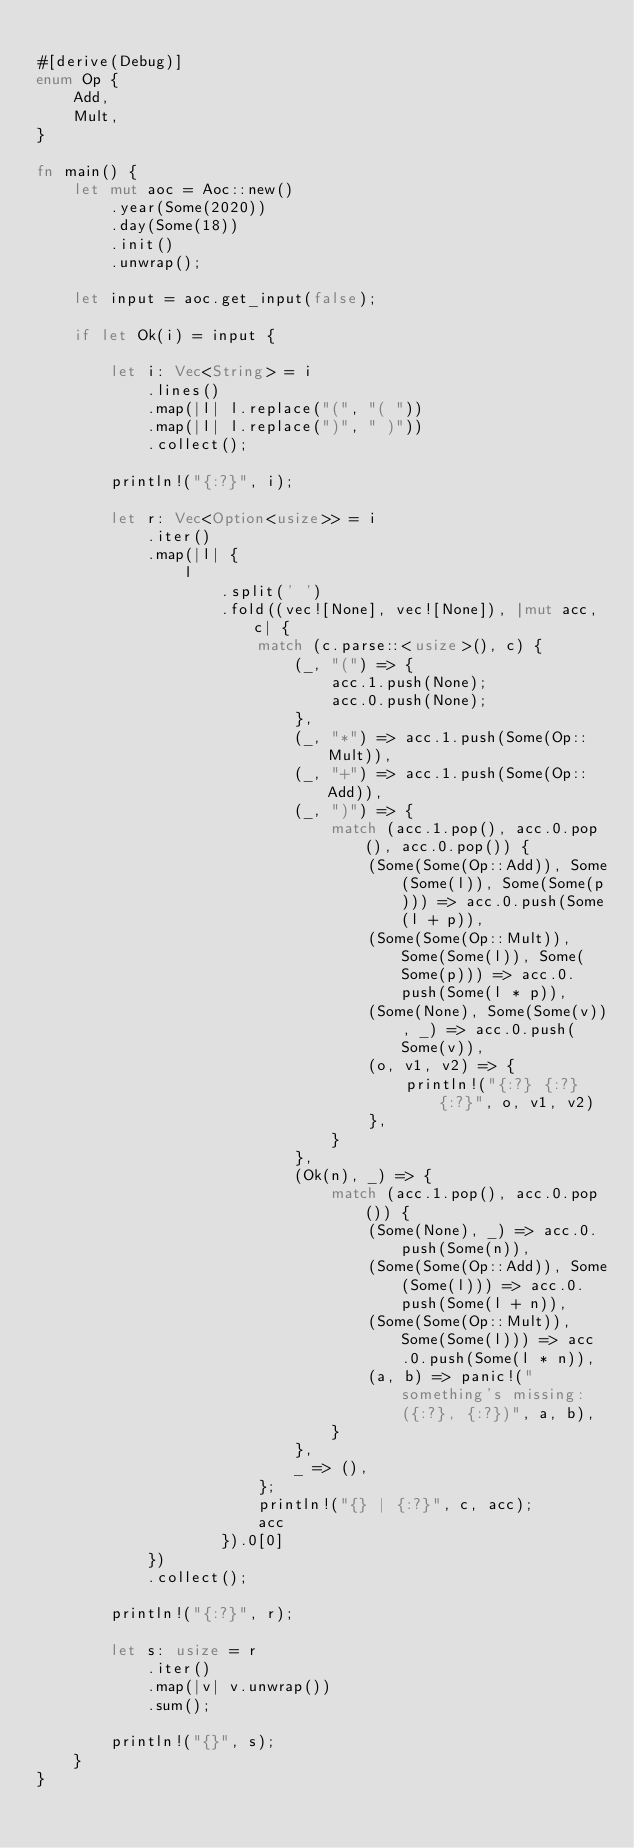<code> <loc_0><loc_0><loc_500><loc_500><_Rust_>
#[derive(Debug)]
enum Op {
    Add,
    Mult,
}

fn main() {
    let mut aoc = Aoc::new()
        .year(Some(2020))
        .day(Some(18))
        .init()
        .unwrap();

    let input = aoc.get_input(false);

    if let Ok(i) = input {

        let i: Vec<String> = i
            .lines()
            .map(|l| l.replace("(", "( "))
            .map(|l| l.replace(")", " )"))
            .collect();

        println!("{:?}", i);

        let r: Vec<Option<usize>> = i
            .iter()
            .map(|l| {
                l
                    .split(' ')
                    .fold((vec![None], vec![None]), |mut acc, c| {
                        match (c.parse::<usize>(), c) {
                            (_, "(") => {
                                acc.1.push(None);
                                acc.0.push(None);
                            },
                            (_, "*") => acc.1.push(Some(Op::Mult)),
                            (_, "+") => acc.1.push(Some(Op::Add)),
                            (_, ")") => {
                                match (acc.1.pop(), acc.0.pop(), acc.0.pop()) {
                                    (Some(Some(Op::Add)), Some(Some(l)), Some(Some(p))) => acc.0.push(Some(l + p)),
                                    (Some(Some(Op::Mult)), Some(Some(l)), Some(Some(p))) => acc.0.push(Some(l * p)),
                                    (Some(None), Some(Some(v)), _) => acc.0.push(Some(v)),
                                    (o, v1, v2) => {
                                        println!("{:?} {:?} {:?}", o, v1, v2)
                                    },
                                }
                            },
                            (Ok(n), _) => {
                                match (acc.1.pop(), acc.0.pop()) {
                                    (Some(None), _) => acc.0.push(Some(n)),
                                    (Some(Some(Op::Add)), Some(Some(l))) => acc.0.push(Some(l + n)),
                                    (Some(Some(Op::Mult)), Some(Some(l))) => acc.0.push(Some(l * n)),
                                    (a, b) => panic!("something's missing: ({:?}, {:?})", a, b),
                                }
                            },
                            _ => (),
                        };
                        println!("{} | {:?}", c, acc);
                        acc
                    }).0[0]
            })
            .collect();

        println!("{:?}", r);

        let s: usize = r
            .iter()
            .map(|v| v.unwrap())
            .sum();

        println!("{}", s);
    }
}
</code> 